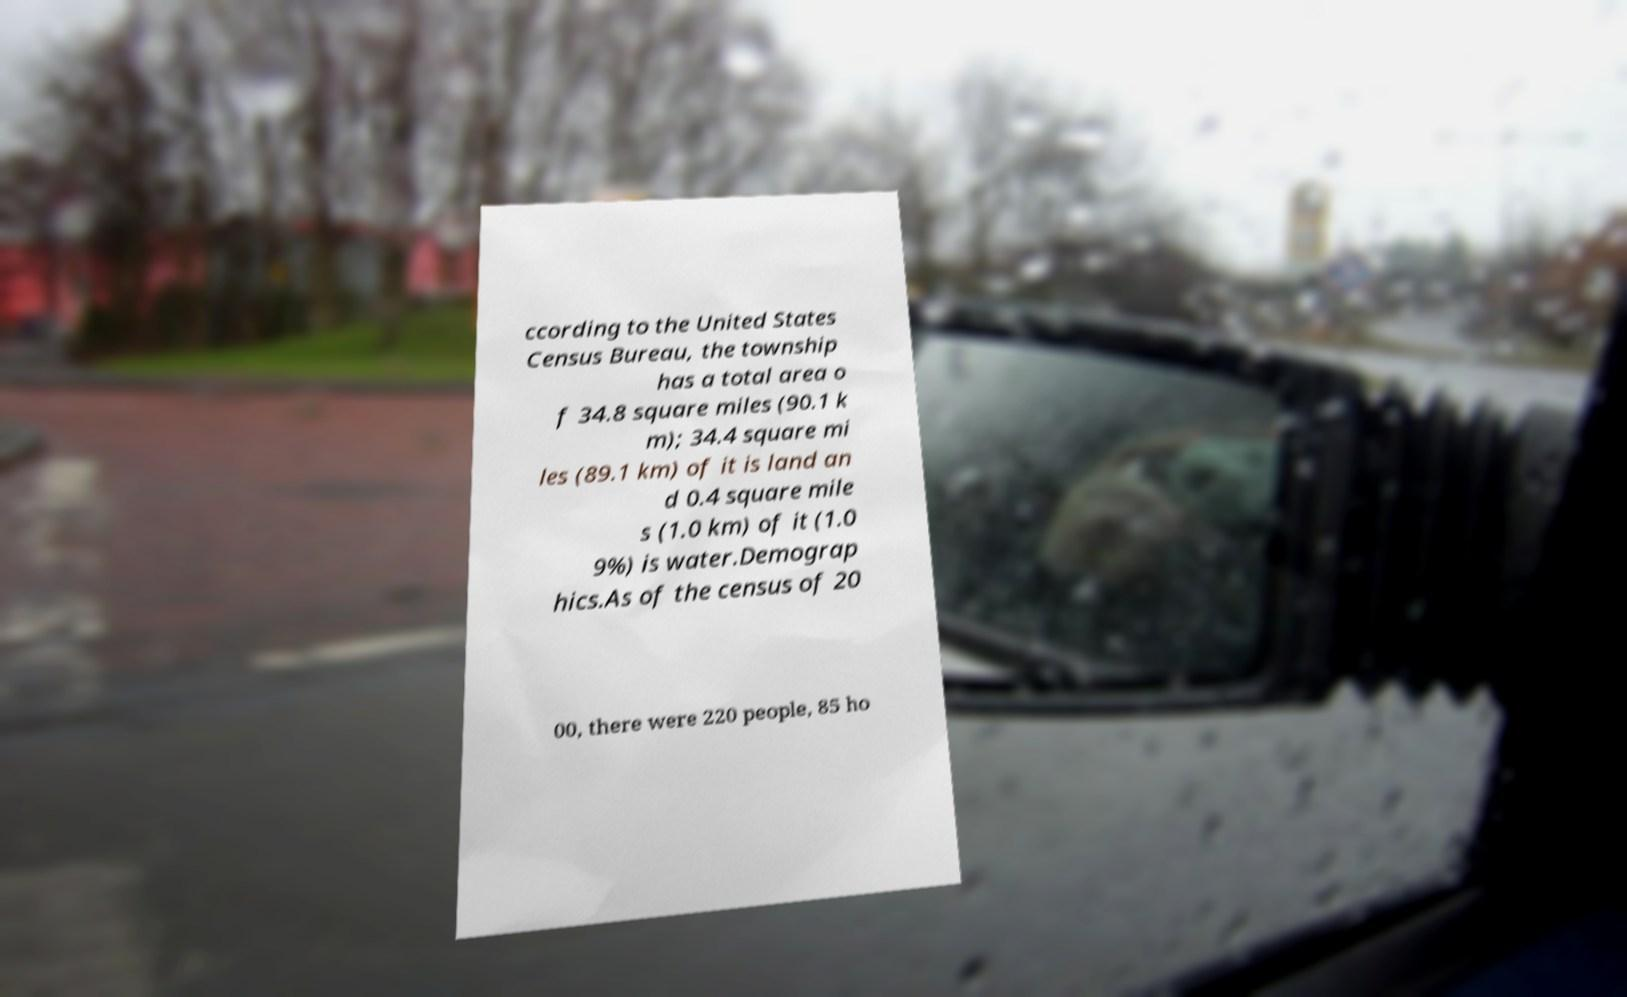Could you extract and type out the text from this image? ccording to the United States Census Bureau, the township has a total area o f 34.8 square miles (90.1 k m); 34.4 square mi les (89.1 km) of it is land an d 0.4 square mile s (1.0 km) of it (1.0 9%) is water.Demograp hics.As of the census of 20 00, there were 220 people, 85 ho 